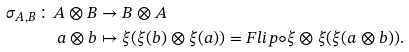<formula> <loc_0><loc_0><loc_500><loc_500>\sigma _ { A , B } \colon A \otimes B & \rightarrow B \otimes A \\ a \otimes b & \mapsto \xi ( \xi ( b ) \otimes \xi ( a ) ) = F l i p \circ \xi \otimes \xi ( \xi ( a \otimes b ) ) .</formula> 